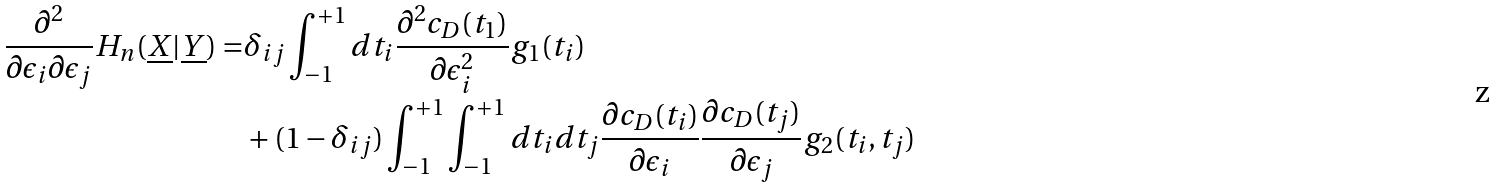<formula> <loc_0><loc_0><loc_500><loc_500>\frac { \partial ^ { 2 } } { \partial \epsilon _ { i } \partial \epsilon _ { j } } H _ { n } ( \underline { X } | \underline { Y } ) = & \delta _ { i j } \int _ { - 1 } ^ { + 1 } d t _ { i } \frac { \partial ^ { 2 } c _ { D } ( t _ { 1 } ) } { \partial \epsilon _ { i } ^ { 2 } } g _ { 1 } ( t _ { i } ) \\ & + ( 1 - \delta _ { i j } ) \int _ { - 1 } ^ { + 1 } \int _ { - 1 } ^ { + 1 } d t _ { i } d t _ { j } \frac { \partial c _ { D } ( t _ { i } ) } { \partial \epsilon _ { i } } \frac { \partial c _ { D } ( t _ { j } ) } { \partial \epsilon _ { j } } g _ { 2 } ( t _ { i } , t _ { j } )</formula> 